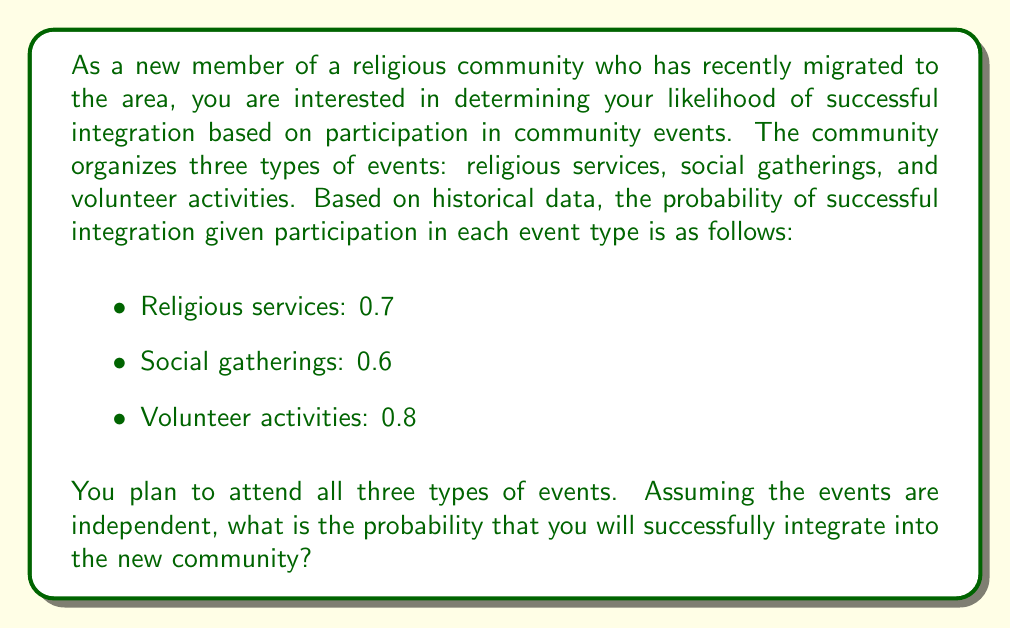Give your solution to this math problem. To solve this problem, we need to calculate the probability of successful integration given participation in all three types of events. Since the events are assumed to be independent, we can use the complement rule of probability.

Let's define the events:
$R$: Successful integration after attending religious services
$S$: Successful integration after attending social gatherings
$V$: Successful integration after attending volunteer activities

We want to find $P(R \cup S \cup V)$, which is the probability of successful integration after participating in at least one type of event.

Using the complement rule:
$$P(R \cup S \cup V) = 1 - P(\text{not } R \cap \text{not } S \cap \text{not } V)$$

The probability of not successfully integrating after attending each type of event:
$P(\text{not } R) = 1 - 0.7 = 0.3$
$P(\text{not } S) = 1 - 0.6 = 0.4$
$P(\text{not } V) = 1 - 0.8 = 0.2$

Since the events are independent:
$$P(\text{not } R \cap \text{not } S \cap \text{not } V) = P(\text{not } R) \times P(\text{not } S) \times P(\text{not } V)$$

Substituting the values:
$$P(\text{not } R \cap \text{not } S \cap \text{not } V) = 0.3 \times 0.4 \times 0.2 = 0.024$$

Now, we can calculate the probability of successful integration:
$$P(R \cup S \cup V) = 1 - 0.024 = 0.976$$

Therefore, the probability of successful integration into the new community after participating in all three types of events is 0.976 or 97.6%.
Answer: The probability of successful integration into the new community is 0.976 or 97.6%. 